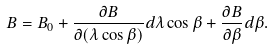Convert formula to latex. <formula><loc_0><loc_0><loc_500><loc_500>B = B _ { 0 } + \frac { \partial B } { \partial ( \lambda \cos \beta ) } d \lambda \cos \beta + \frac { \partial B } { \partial \beta } d \beta .</formula> 